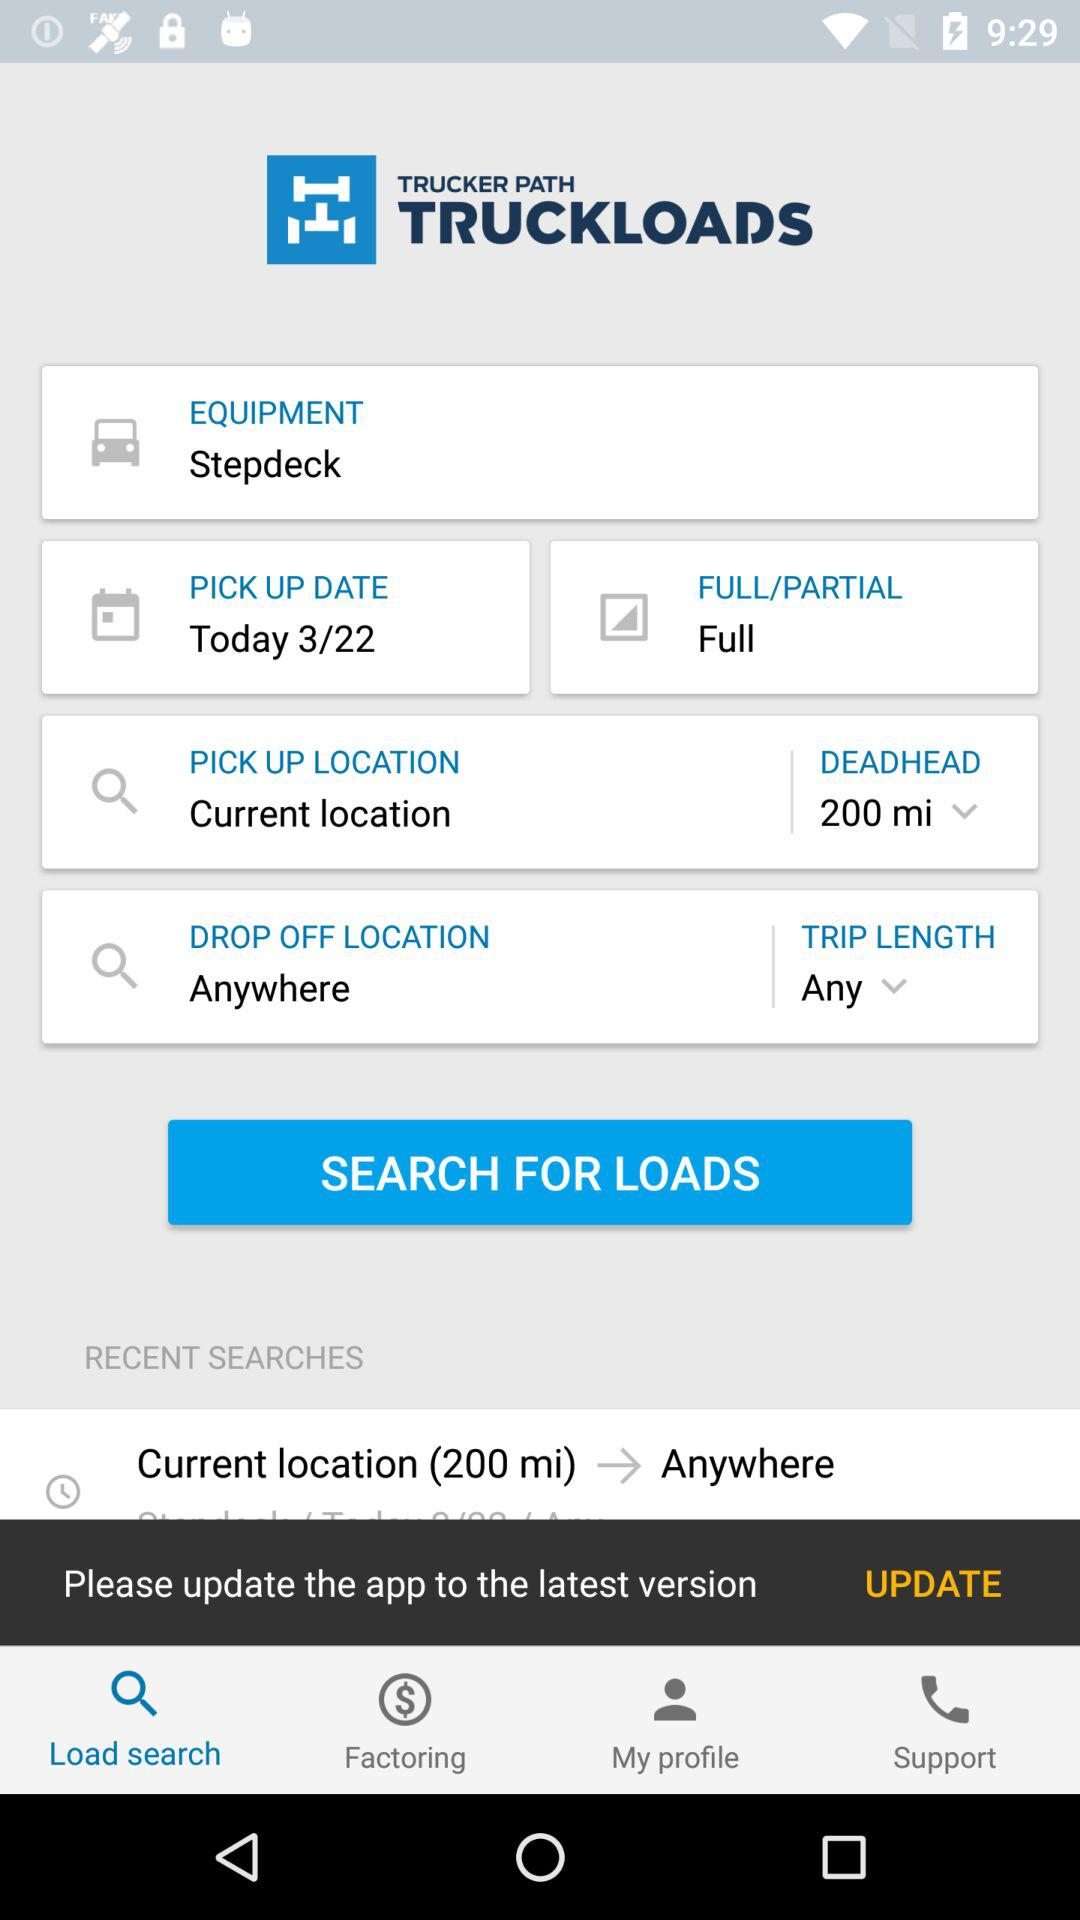What is the drop-off location? The drop off location is "Anywhere". 